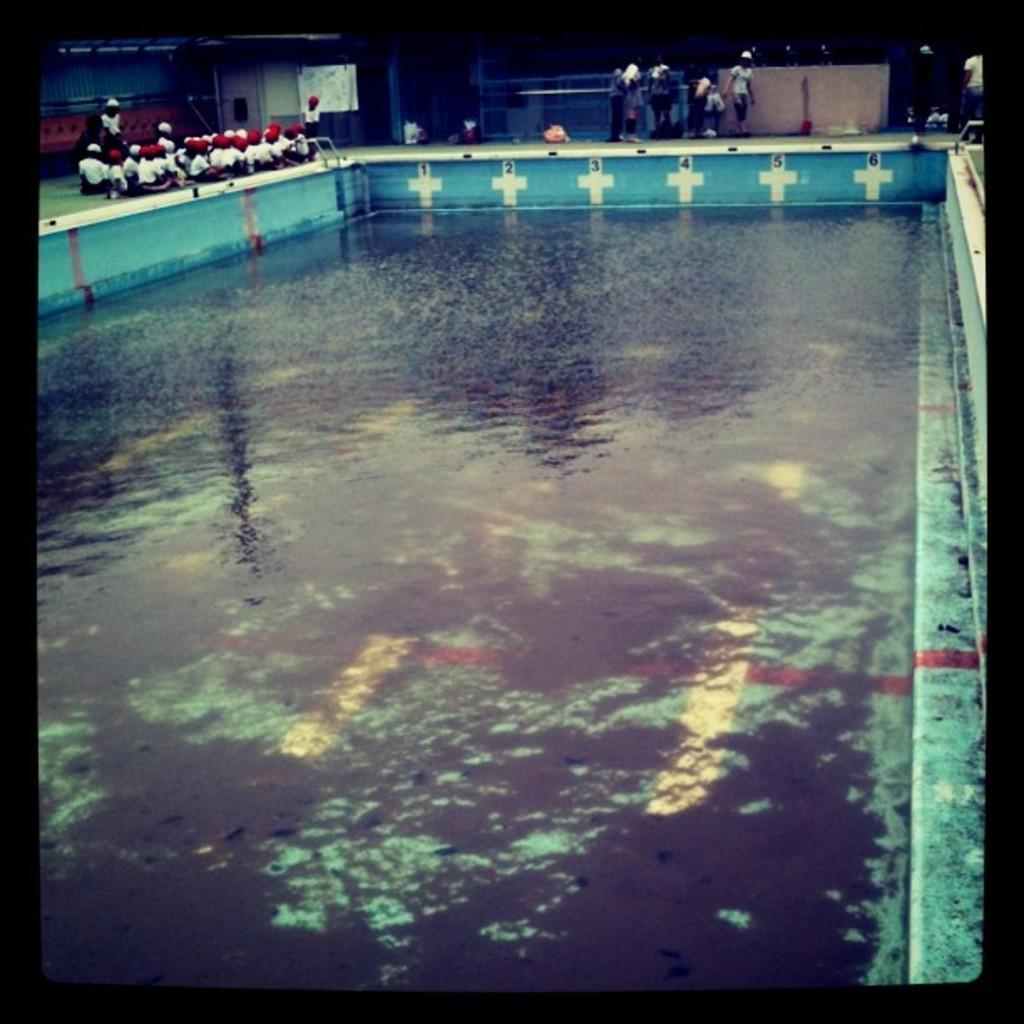Please provide a concise description of this image. In this image at the bottom it looks like a swimming pool, in the background there are some persons, wall and some lights. 